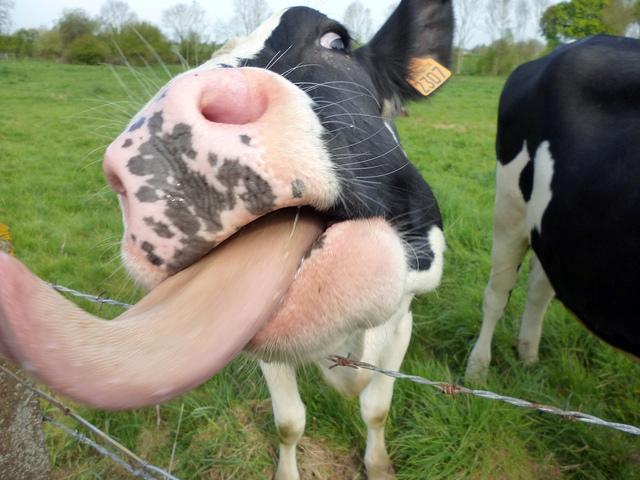What is on the cow's ear?
Be succinct. Tag. Does the cow have whiskers?
Quick response, please. Yes. What is the tag number on the cow?
Quick response, please. 2307. 